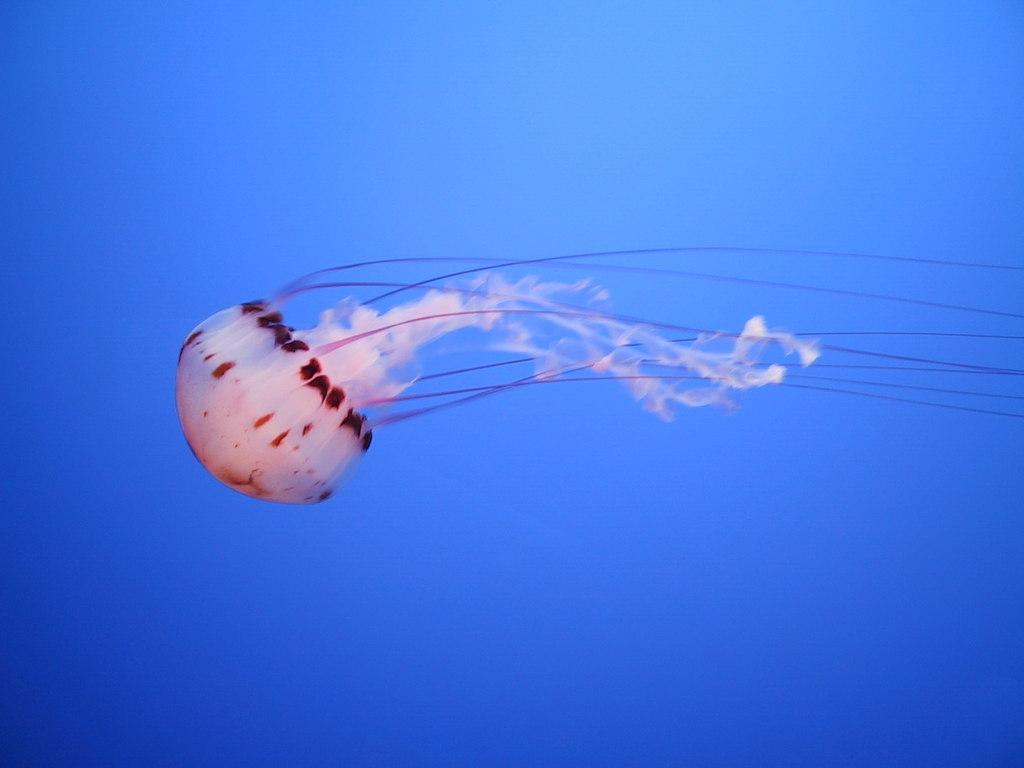What is the main subject of the image? There is a jellyfish in the image. Where is the jellyfish located? The jellyfish is in the water. What type of beam is holding up the jellyfish in the image? There is no beam present in the image, as the jellyfish is in the water. Is there a rifle visible in the image? There is no rifle present in the image; it features a jellyfish in the water. 